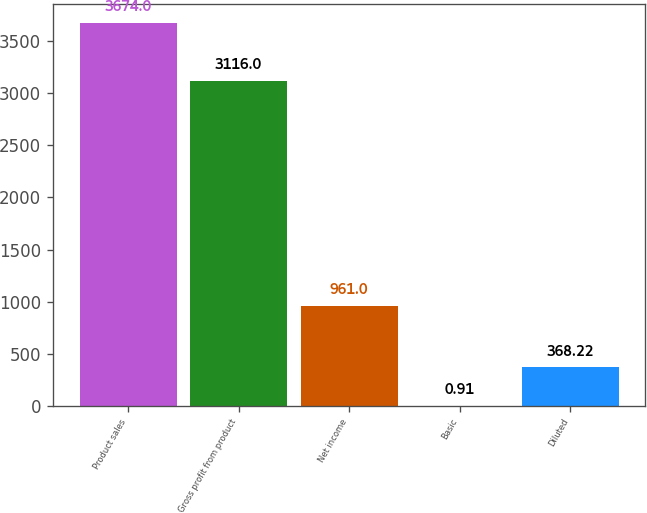Convert chart to OTSL. <chart><loc_0><loc_0><loc_500><loc_500><bar_chart><fcel>Product sales<fcel>Gross profit from product<fcel>Net income<fcel>Basic<fcel>Diluted<nl><fcel>3674<fcel>3116<fcel>961<fcel>0.91<fcel>368.22<nl></chart> 